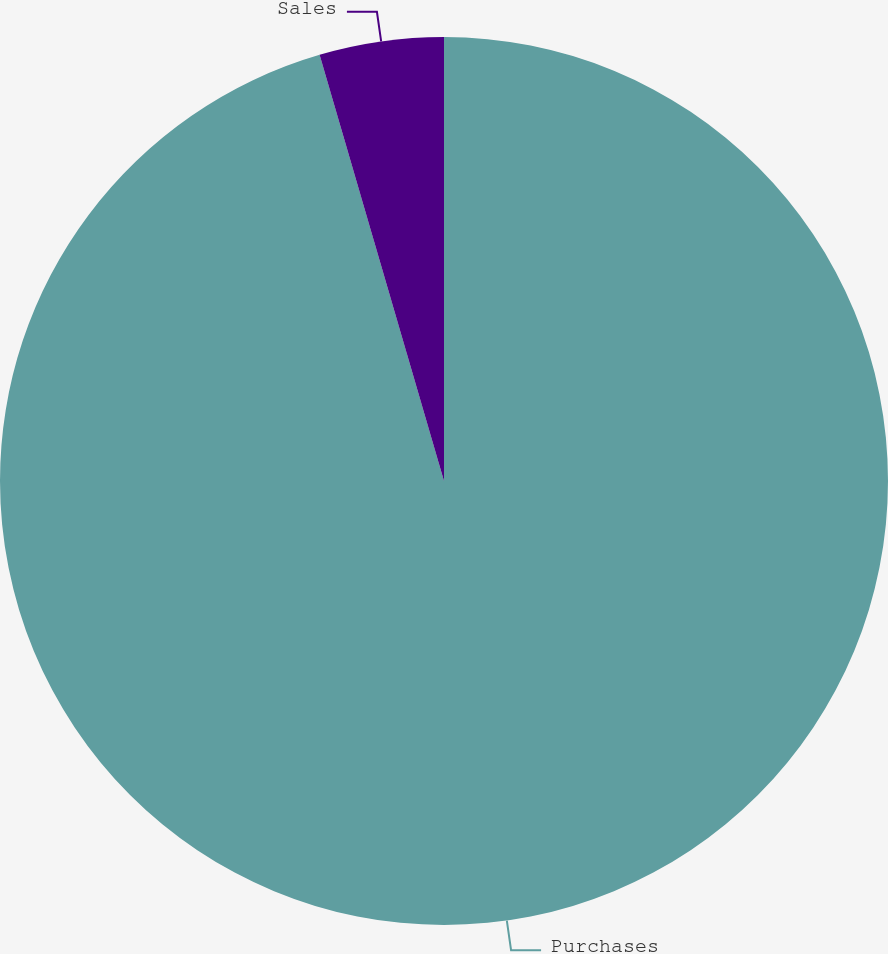Convert chart to OTSL. <chart><loc_0><loc_0><loc_500><loc_500><pie_chart><fcel>Purchases<fcel>Sales<nl><fcel>95.48%<fcel>4.52%<nl></chart> 